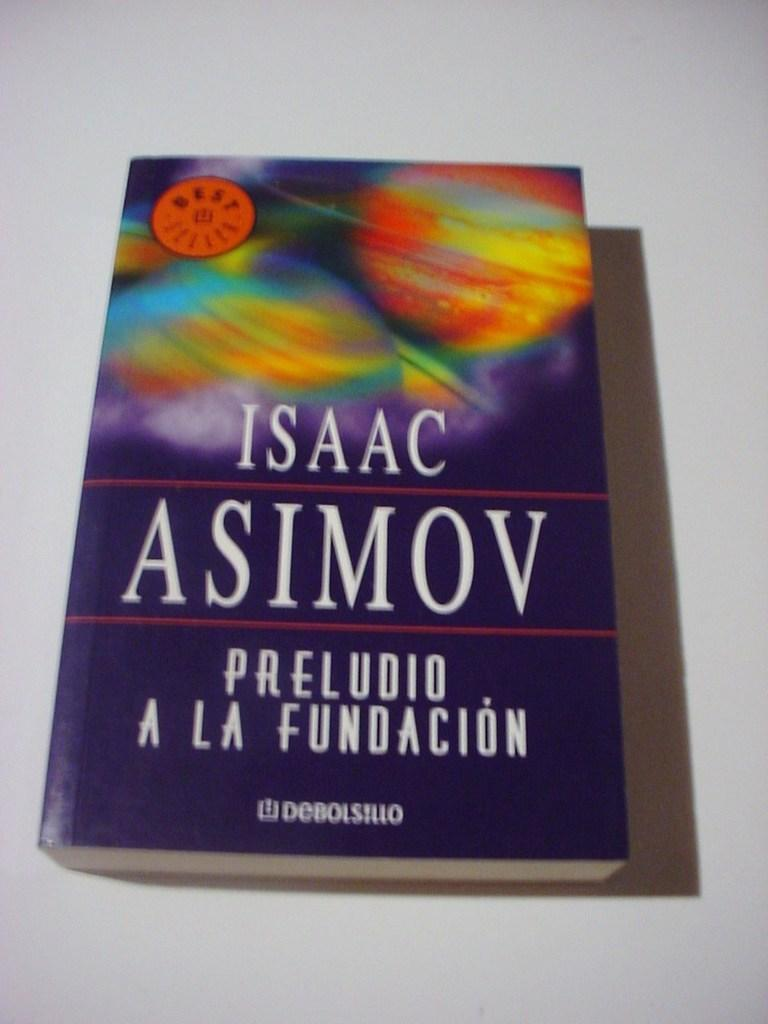<image>
Summarize the visual content of the image. A book called Preludio a la fundacion that was written by Isaac Asimov 